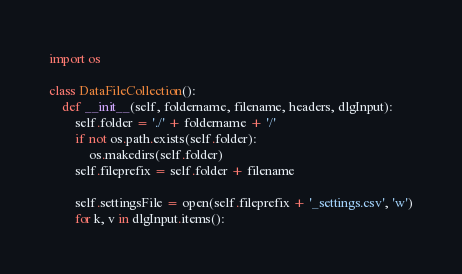<code> <loc_0><loc_0><loc_500><loc_500><_Python_>import os

class DataFileCollection():
    def __init__(self, foldername, filename, headers, dlgInput):
        self.folder = './' + foldername + '/'
        if not os.path.exists(self.folder):
            os.makedirs(self.folder)
        self.fileprefix = self.folder + filename

        self.settingsFile = open(self.fileprefix + '_settings.csv', 'w')
        for k, v in dlgInput.items():</code> 